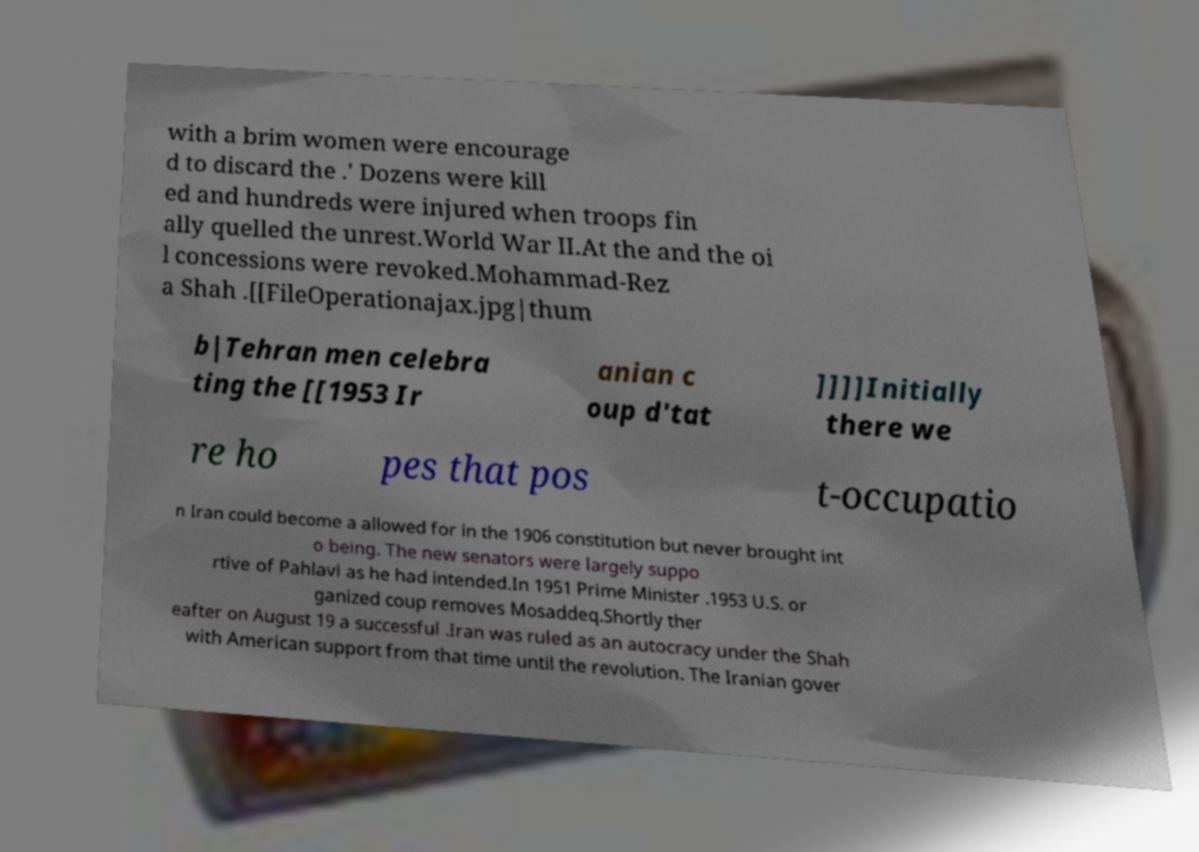I need the written content from this picture converted into text. Can you do that? with a brim women were encourage d to discard the .' Dozens were kill ed and hundreds were injured when troops fin ally quelled the unrest.World War II.At the and the oi l concessions were revoked.Mohammad-Rez a Shah .[[FileOperationajax.jpg|thum b|Tehran men celebra ting the [[1953 Ir anian c oup d'tat ]]]]Initially there we re ho pes that pos t-occupatio n Iran could become a allowed for in the 1906 constitution but never brought int o being. The new senators were largely suppo rtive of Pahlavi as he had intended.In 1951 Prime Minister .1953 U.S. or ganized coup removes Mosaddeq.Shortly ther eafter on August 19 a successful .Iran was ruled as an autocracy under the Shah with American support from that time until the revolution. The Iranian gover 